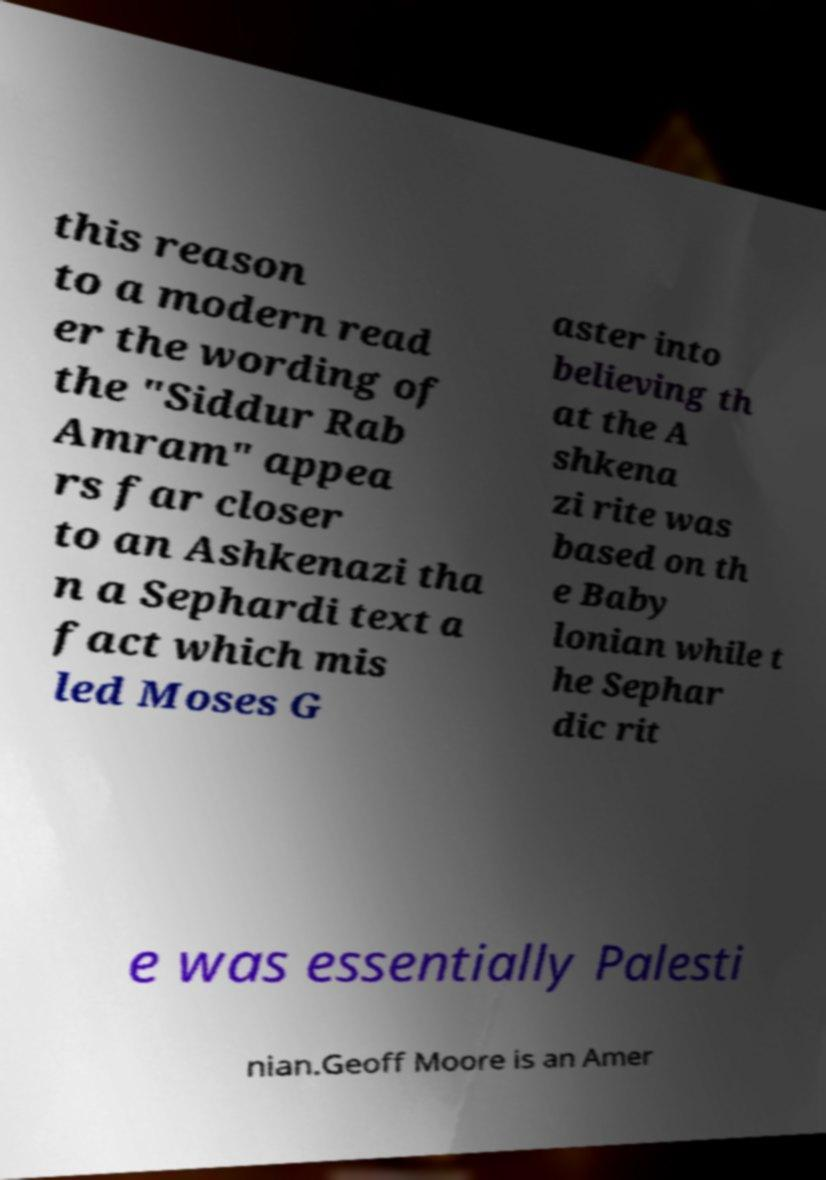Could you extract and type out the text from this image? this reason to a modern read er the wording of the "Siddur Rab Amram" appea rs far closer to an Ashkenazi tha n a Sephardi text a fact which mis led Moses G aster into believing th at the A shkena zi rite was based on th e Baby lonian while t he Sephar dic rit e was essentially Palesti nian.Geoff Moore is an Amer 